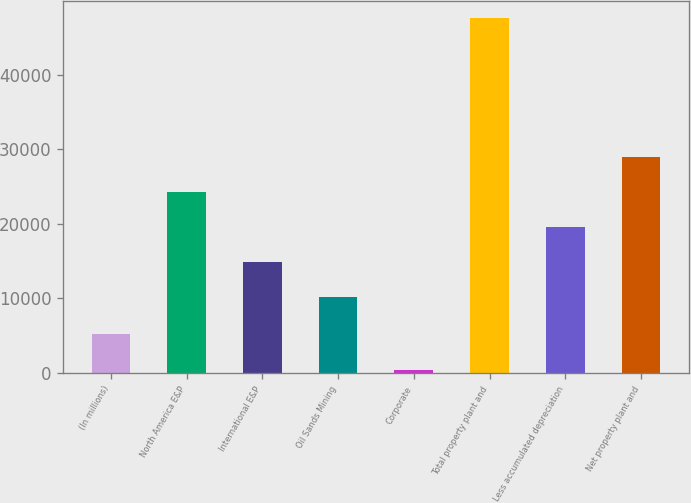Convert chart. <chart><loc_0><loc_0><loc_500><loc_500><bar_chart><fcel>(In millions)<fcel>North America E&P<fcel>International E&P<fcel>Oil Sands Mining<fcel>Corporate<fcel>Total property plant and<fcel>Less accumulated depreciation<fcel>Net property plant and<nl><fcel>5157.9<fcel>24253.7<fcel>14835.9<fcel>10127<fcel>449<fcel>47538<fcel>19544.8<fcel>28962.6<nl></chart> 